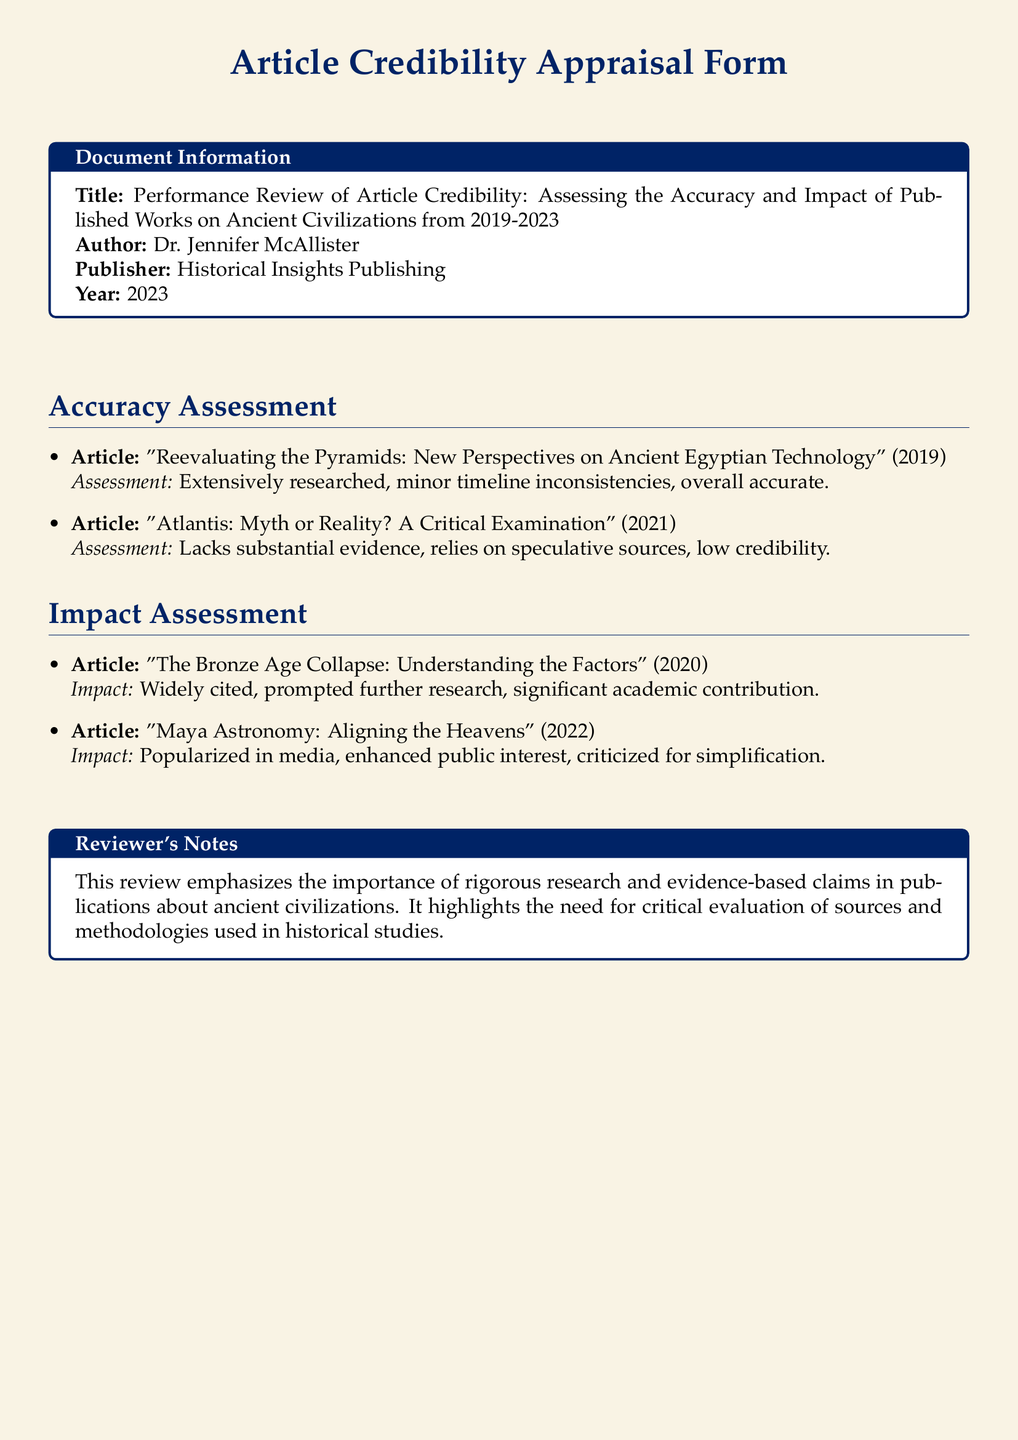What is the title of the document? The title is the heading of the document where it introduces the main subject.
Answer: Performance Review of Article Credibility: Assessing the Accuracy and Impact of Published Works on Ancient Civilizations from 2019-2023 Who is the author of the document? The author is the person who conducted the research and wrote the document.
Answer: Dr. Jennifer McAllister What year was the document published? The year indicates when the document became available to the public.
Answer: 2023 How many articles were assessed in the Accuracy Assessment section? The number of articles listed in the specific section provides insight into the scope of the review.
Answer: 2 Which article was widely cited and prompted further research? The specific article mentioned that had a significant impact on further studies.
Answer: The Bronze Age Collapse: Understanding the Factors What is the impact of the article "Maya Astronomy: Aligning the Heavens"? Understanding the impact helps gauge the societal and academic effect of the publication.
Answer: Popularized in media, enhanced public interest, criticized for simplification What issues were noted in the article about Atlantis? Identifying issues helps assess its credibility and reliability in publications.
Answer: Lacks substantial evidence, relies on speculative sources, low credibility What type of notes are included in the Reviewer's Notes section? Knowing the content type in this section informs about the overall evaluation of the works assessed.
Answer: Review notes emphasize rigorous research and evidence-based claims 